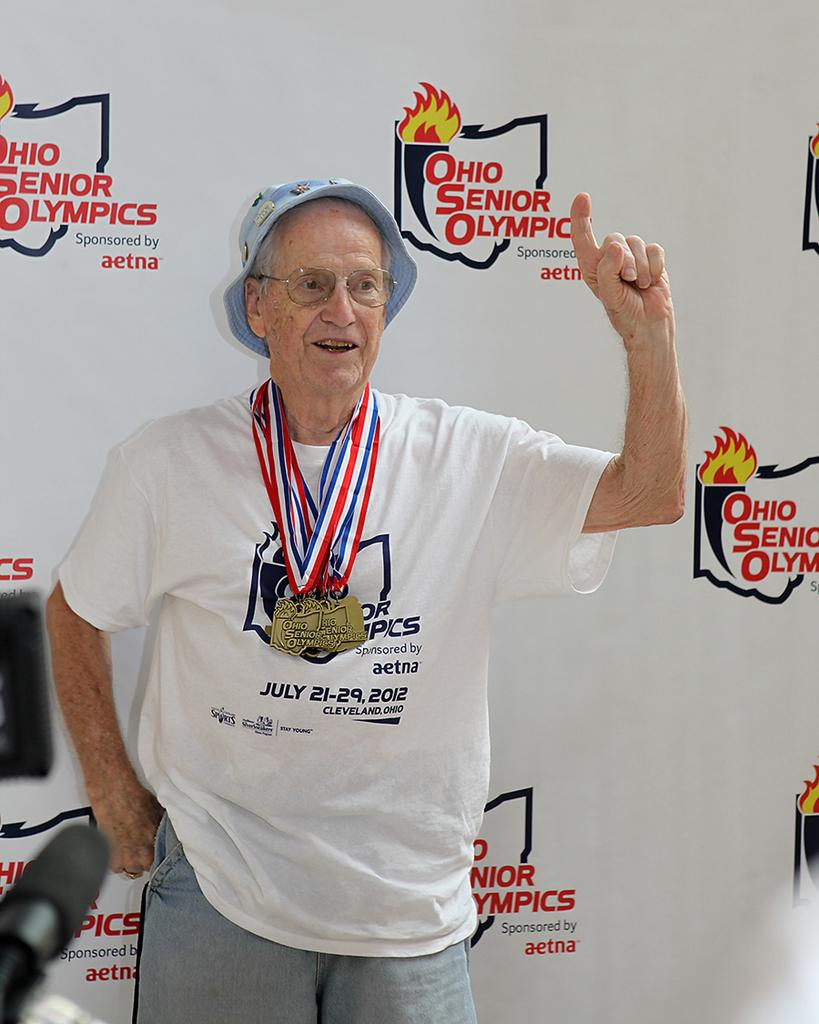<image>
Describe the image concisely. Old man wearing a shirt that has the month of July on it. 